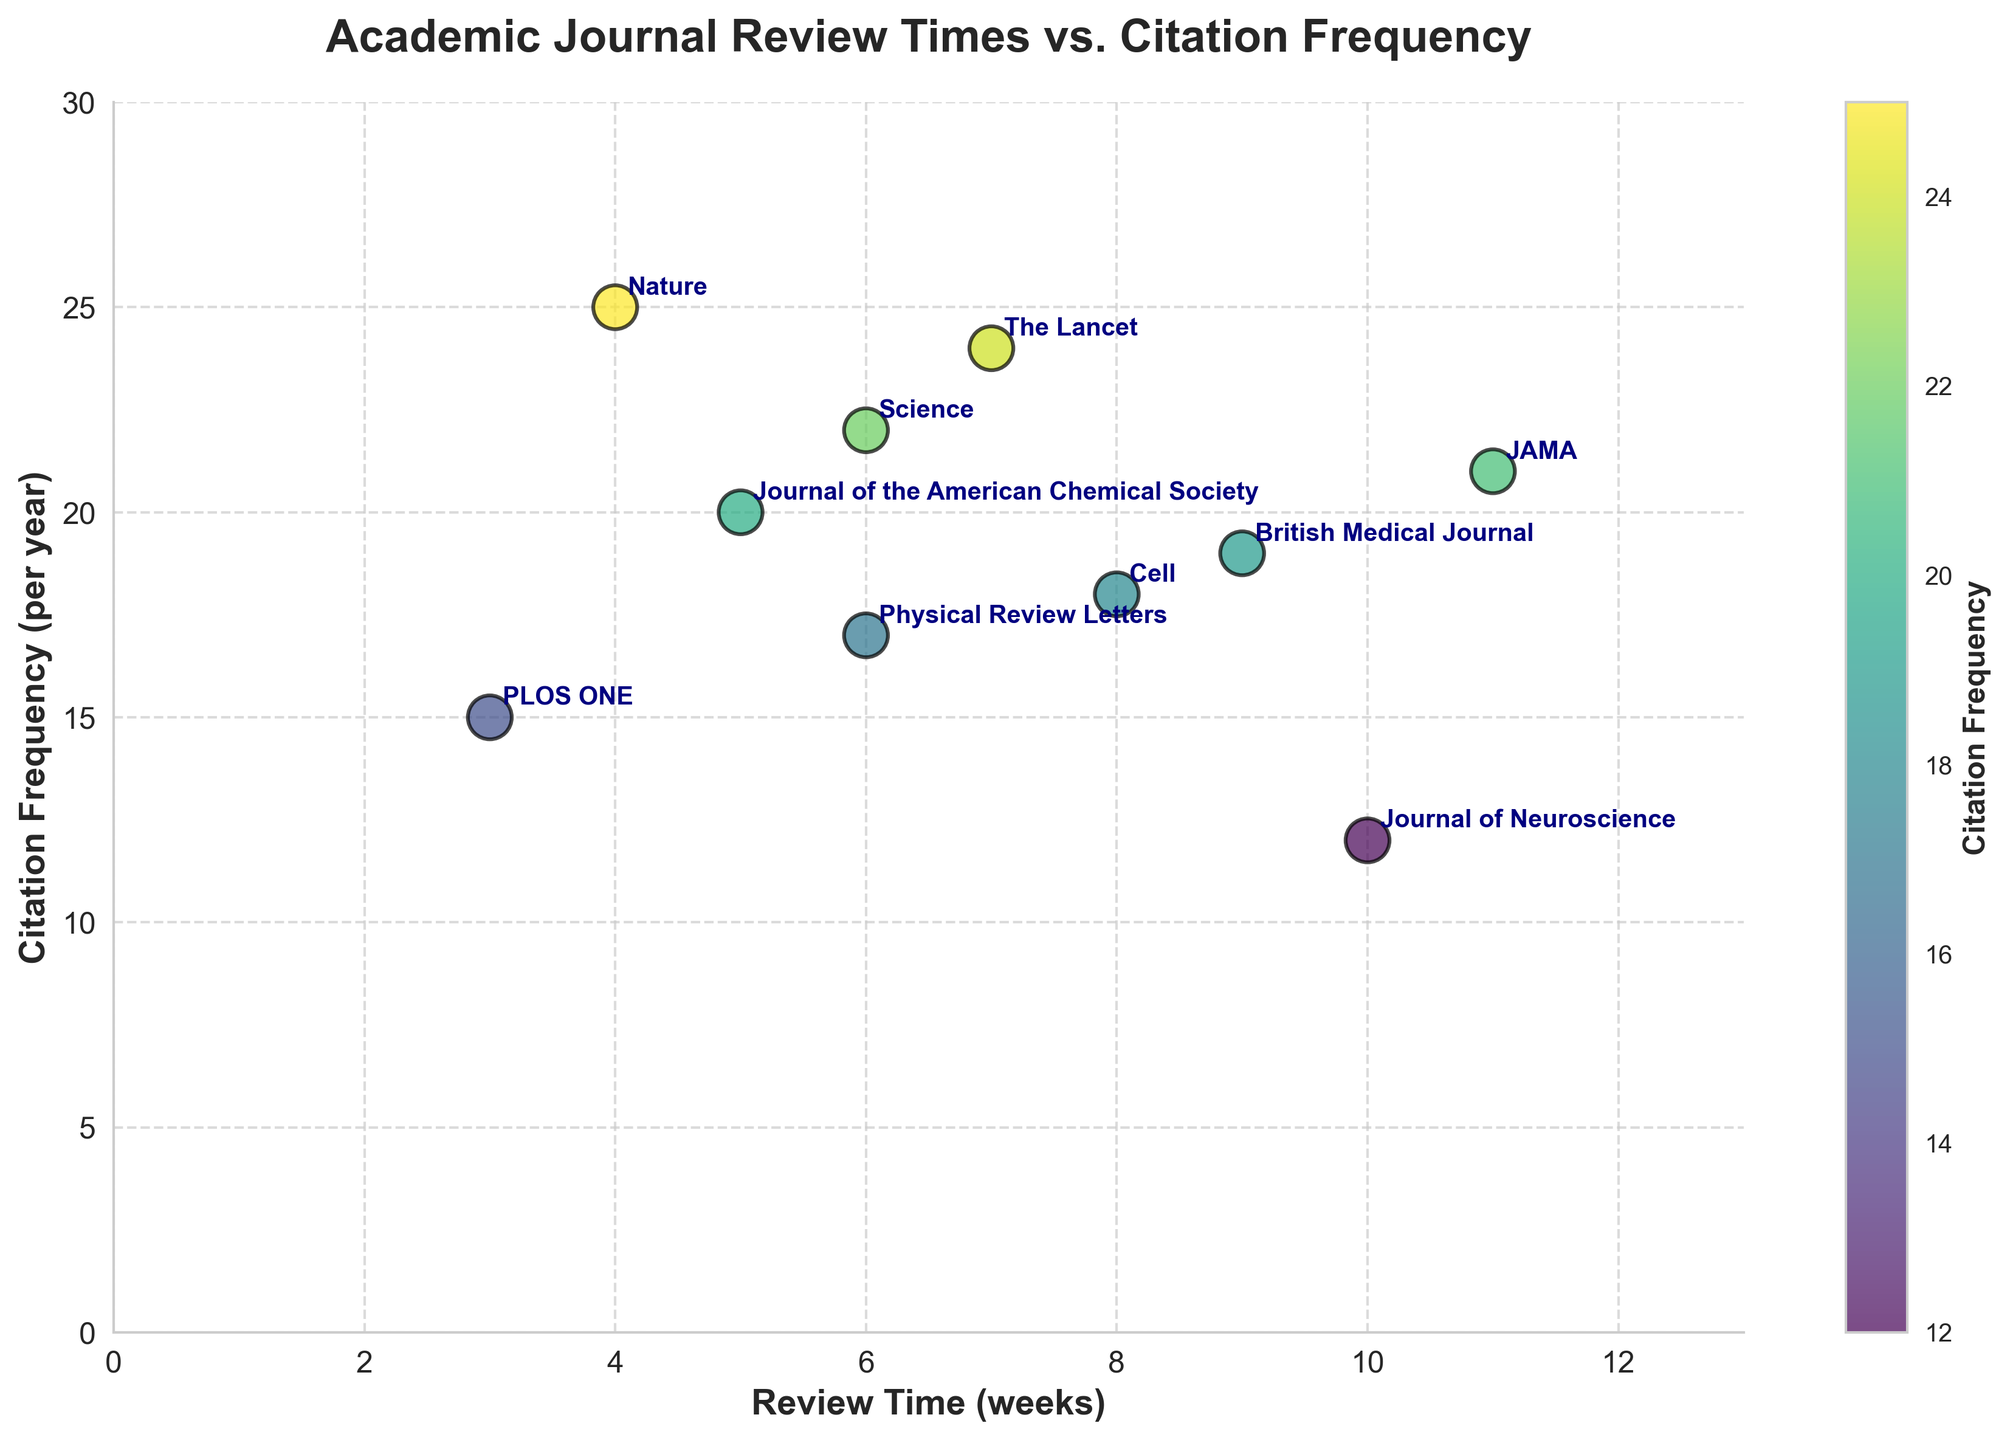What's the title of the figure? The title of the figure is displayed at the top in bold text and describes the data presented in the scatter plot.
Answer: Academic Journal Review Times vs. Citation Frequency How many journals are plotted in the figure? Each data point in the scatter plot represents one journal, and there are 10 data points.
Answer: 10 What is the journal with the shortest review time and its citation frequency? The journal with the shortest review time has the lowest x-coordinate on the scatter plot. It's 'PLOS ONE' with a review time of 3 weeks and a citation frequency of 15 per year.
Answer: PLOS ONE, 15 Which journal has the highest citation frequency, and what is its review time? The journal with the highest citation frequency has the highest y-coordinate on the scatter plot. It's 'Nature' with a citation frequency of 25 per year and a review time of 4 weeks.
Answer: Nature, 4 What is the range of the review times for the journals? The range is computed by subtracting the minimum review time from the maximum review time. The minimum review time is 3 weeks ('PLOS ONE'), and the maximum is 11 weeks ('JAMA'). Thus, the range is 11 - 3 = 8 weeks.
Answer: 8 weeks Which journal has a citation frequency of 24 per year, and what is its review time? By locating the data point with a y-coordinate of 24, the journal 'The Lancet' is identified, which has a review time of 7 weeks.
Answer: The Lancet, 7 What is the average review time of all the journals? To find the average, sum all the review times and divide by the number of journals: (4+6+8+3+10+5+7+9+6+11) / 10 = 69/10 = 6.9 weeks.
Answer: 6.9 weeks Is there any journal with a review time greater than that of 'The Lancet' and a lower citation frequency than it? Compare the review times and citation frequencies. The 'Journal of Neuroscience' (10 weeks, 12 citations) and 'JAMA' (11 weeks, 21 citations) have higher review times, but only the former has a lower citation frequency.
Answer: Journal of Neuroscience Do journals with shorter review times generally have higher citation frequencies in the plot? By visually assessing the scatter plot, there is an observable trend showing that journals with shorter review times tend to have higher citation frequencies.
Answer: Yes What is the median review time of the journals? Median is the middle value in a sorted list. Sorted review times: 3, 4, 5, 6, 6, 7, 8, 9, 10, 11. The median is (6+6)/2 = 6 weeks.
Answer: 6 weeks 